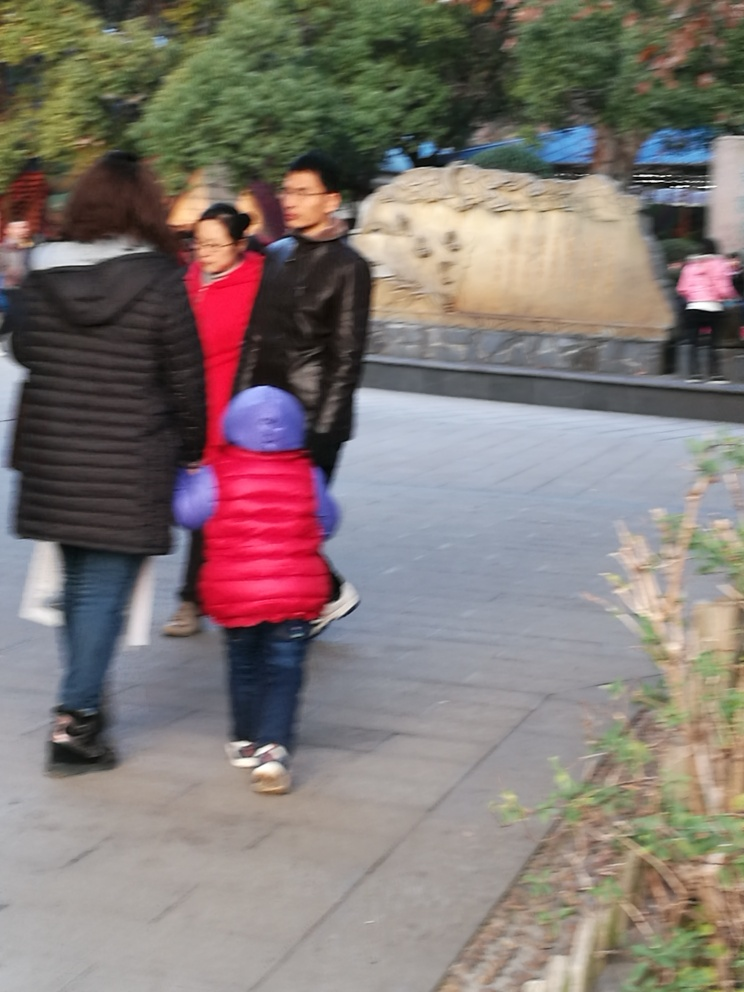What can you infer about the weather in this image? The image shows people dressed in layers and jackets. Considering their attire, it seems the weather is cool or cold. Additionally, the lighting in the image looks clear, which might suggest that the weather is fair without signs of rain or fog. 